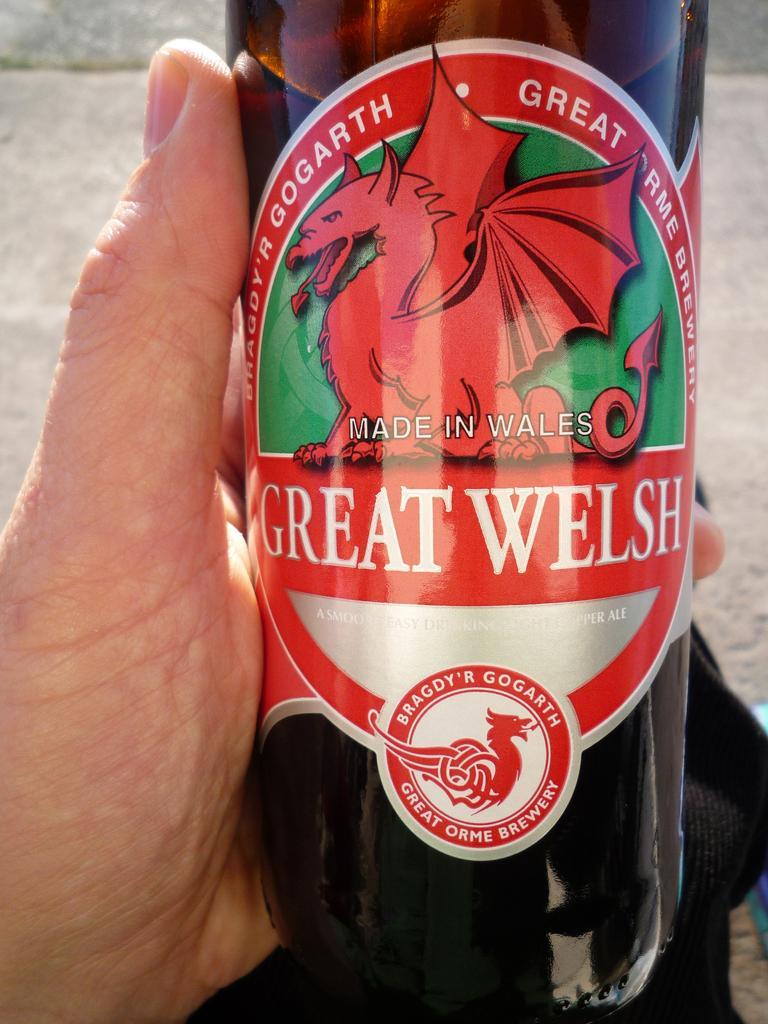How would you summarize this image in a sentence or two? It is a picture of a bottle someone is holding the bottle with their hand. 